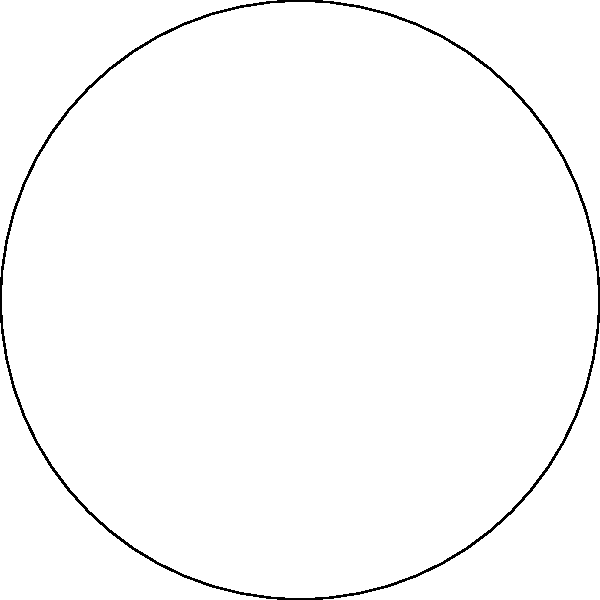At the Royal St. Andrews Golf Club, there's a circular water hazard with a radius of 30 meters. If a player's ball travels along an arc of this water hazard that subtends a central angle of 120°, what is the length of the arc to the nearest meter? To solve this problem, we'll use the formula for arc length:

$s = r\theta$

Where:
$s$ = arc length
$r$ = radius of the circle
$\theta$ = central angle in radians

Step 1: Convert the central angle from degrees to radians.
$\theta = 120° \times \frac{\pi}{180°} = \frac{2\pi}{3}$ radians

Step 2: Apply the arc length formula.
$s = r\theta = 30 \times \frac{2\pi}{3}$

Step 3: Simplify and calculate.
$s = 20\pi \approx 62.83$ meters

Step 4: Round to the nearest meter.
$s \approx 63$ meters
Answer: 63 meters 